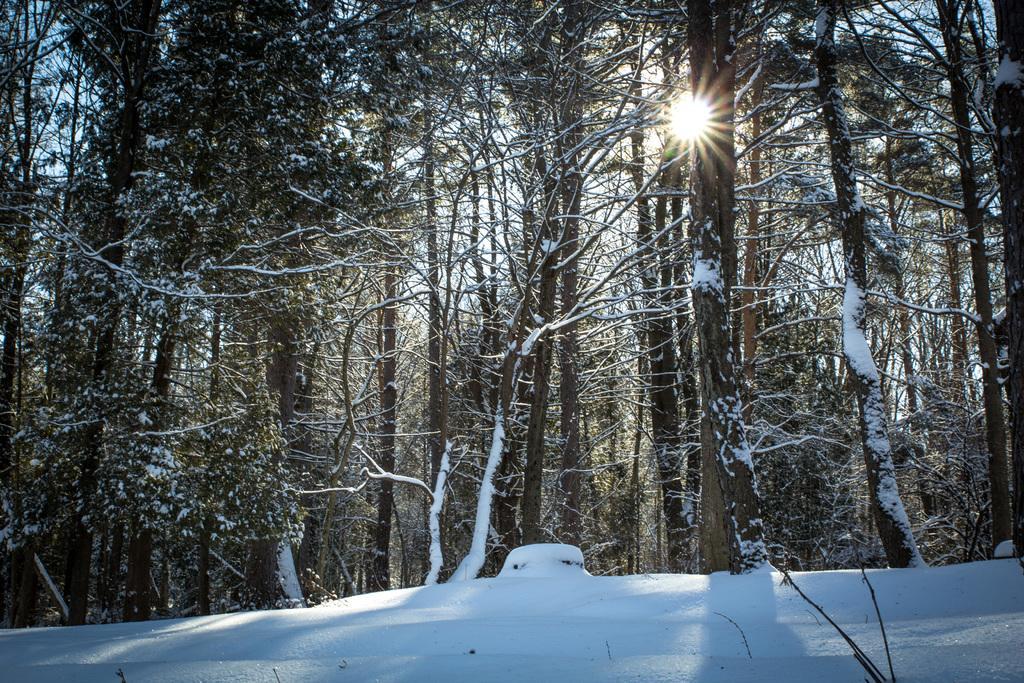Describe this image in one or two sentences. In this image we can see the trees and also the snow. We can also see the sun. 